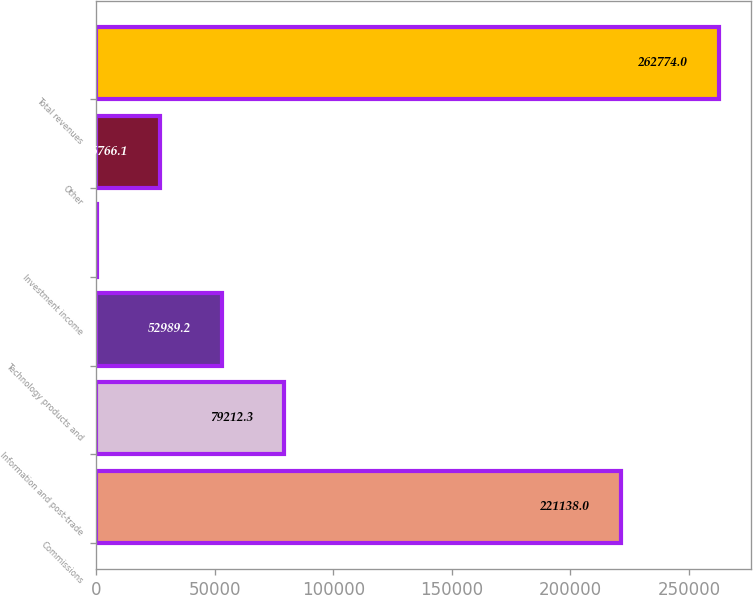<chart> <loc_0><loc_0><loc_500><loc_500><bar_chart><fcel>Commissions<fcel>Information and post-trade<fcel>Technology products and<fcel>Investment income<fcel>Other<fcel>Total revenues<nl><fcel>221138<fcel>79212.3<fcel>52989.2<fcel>543<fcel>26766.1<fcel>262774<nl></chart> 